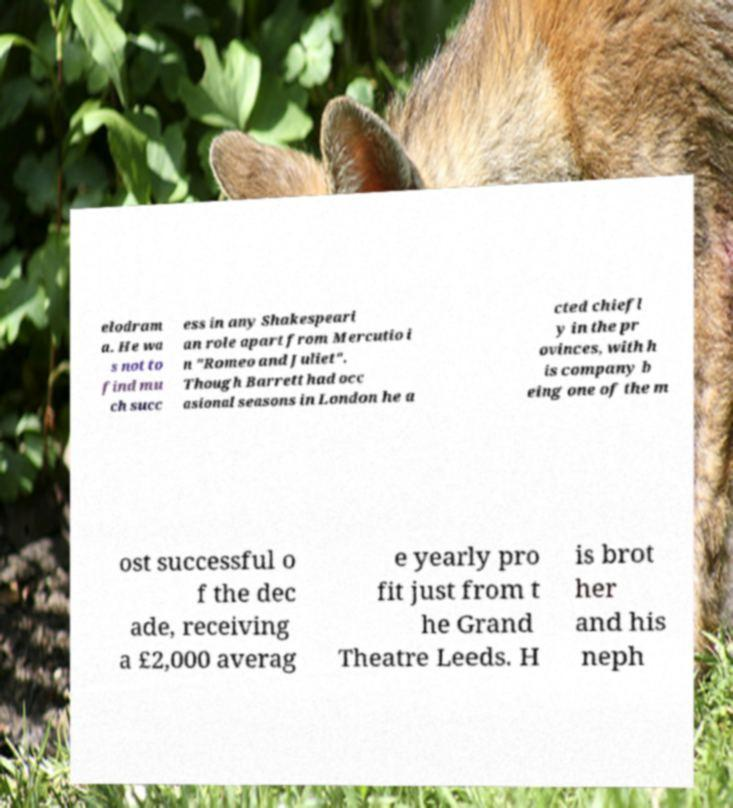Can you accurately transcribe the text from the provided image for me? elodram a. He wa s not to find mu ch succ ess in any Shakespeari an role apart from Mercutio i n "Romeo and Juliet". Though Barrett had occ asional seasons in London he a cted chiefl y in the pr ovinces, with h is company b eing one of the m ost successful o f the dec ade, receiving a £2,000 averag e yearly pro fit just from t he Grand Theatre Leeds. H is brot her and his neph 